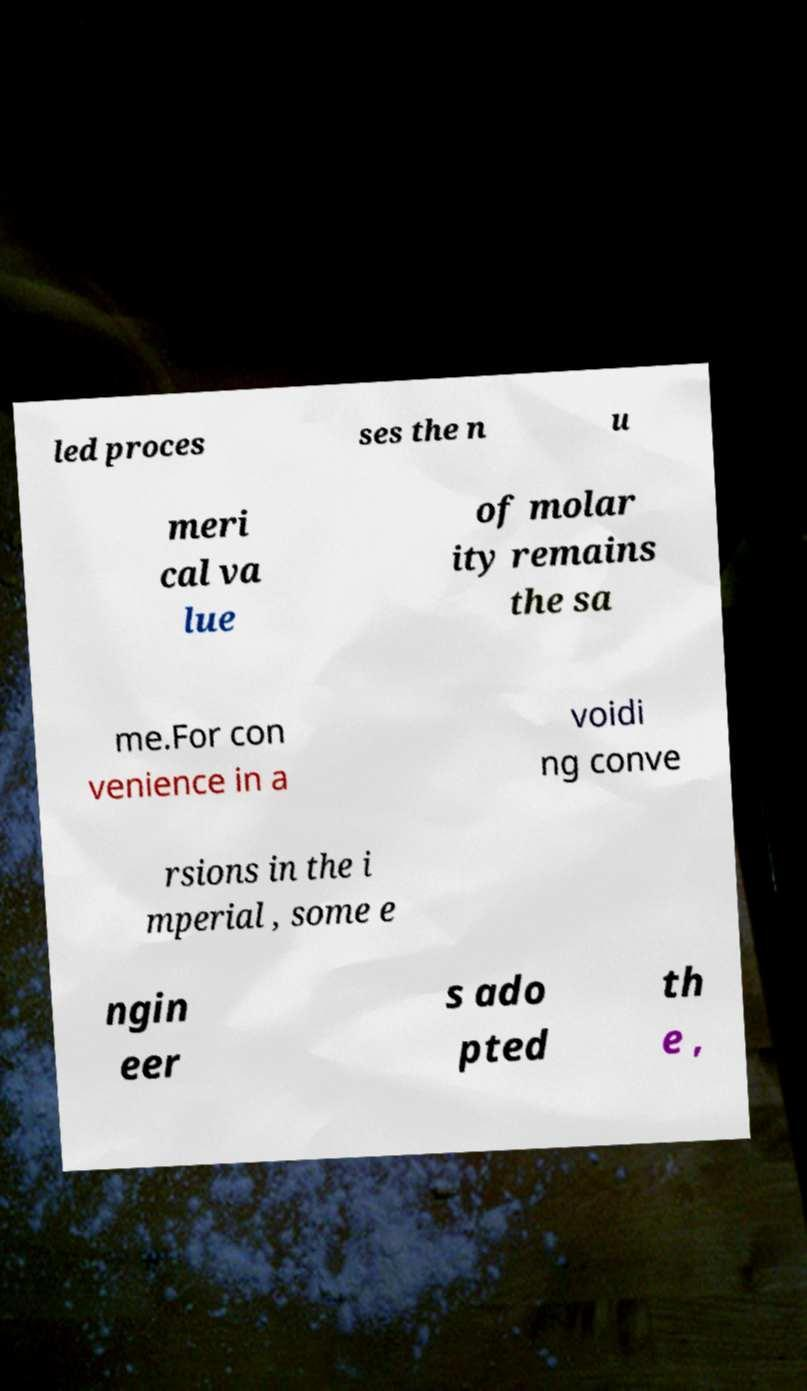For documentation purposes, I need the text within this image transcribed. Could you provide that? led proces ses the n u meri cal va lue of molar ity remains the sa me.For con venience in a voidi ng conve rsions in the i mperial , some e ngin eer s ado pted th e , 